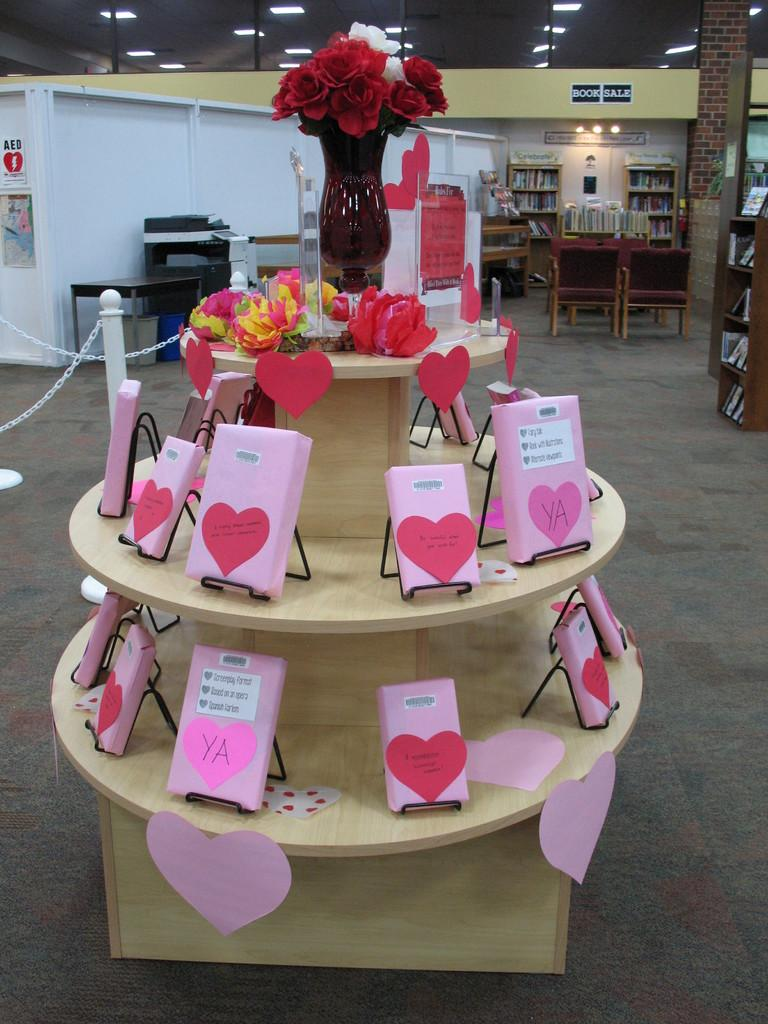What is the main object in the image? There is a flower vase in the image. What is inside the vase? There are flowers in the image. What else can be seen on the table in the image? There are cards on the table in the image. What can be seen in the background of the image? There are metal rods, a machine, and books in the background of the image. What type of mine can be seen in the image? There is no mine present in the image. Can you tell me how many forks are visible in the image? There are no forks visible in the image. 